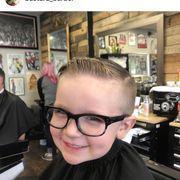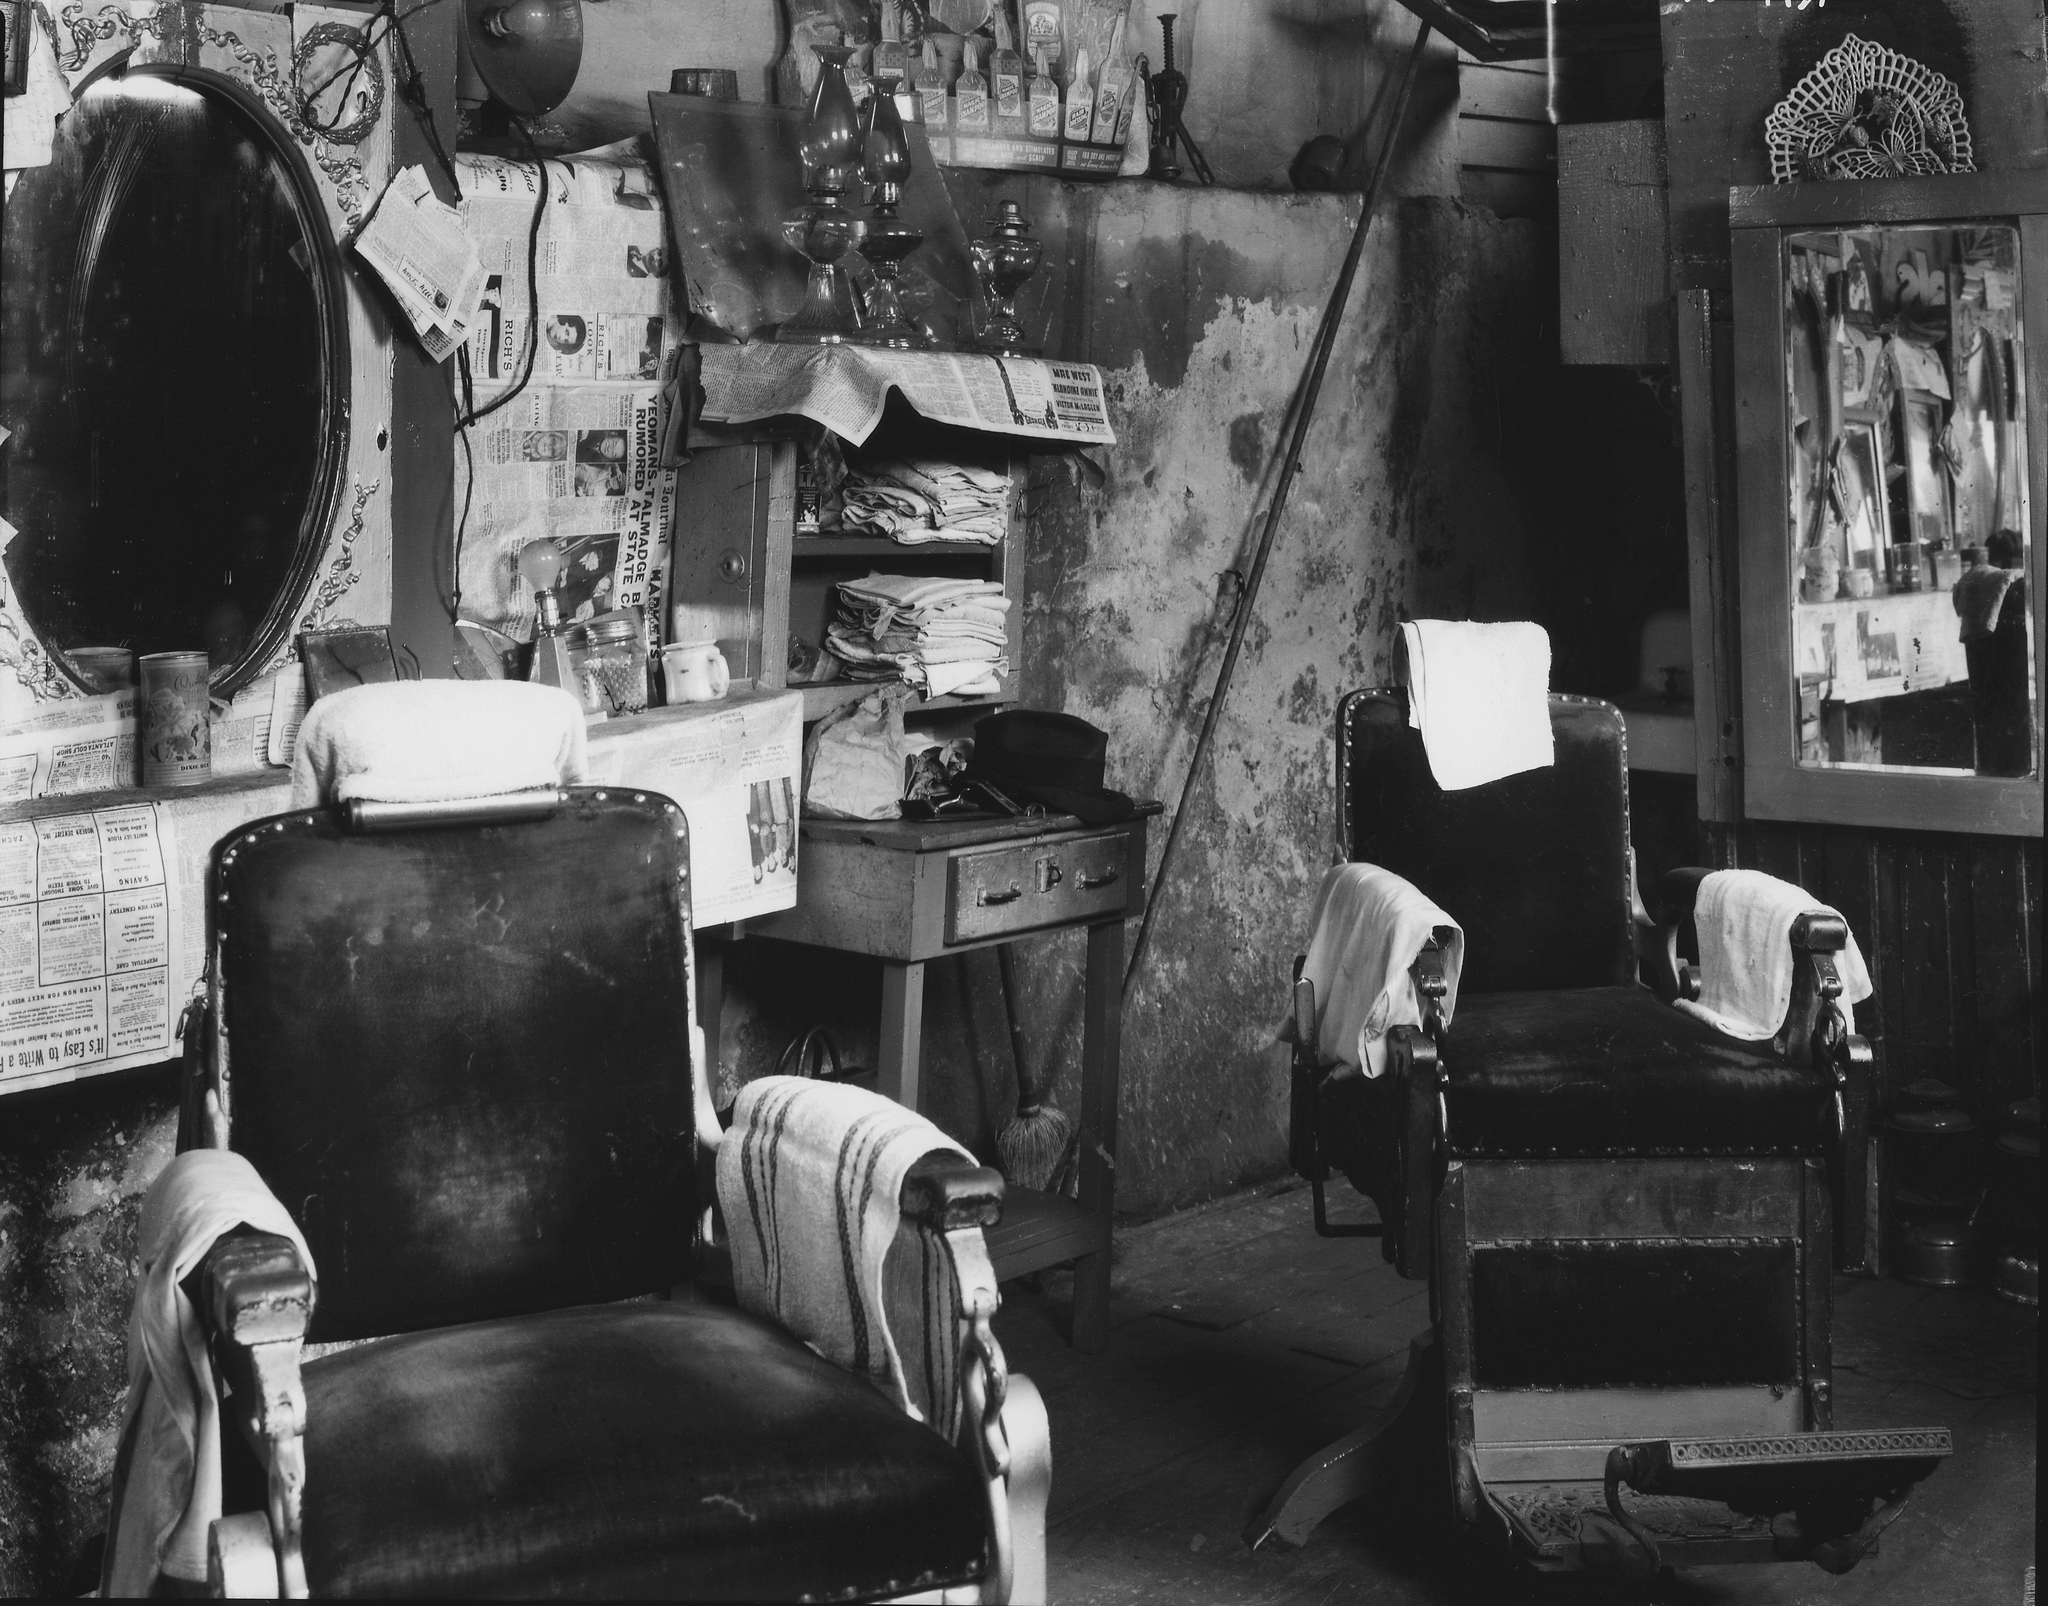The first image is the image on the left, the second image is the image on the right. Given the left and right images, does the statement "The left image includes a man in a hat, glasses and beard standing behind a forward-facing customer in a black smock." hold true? Answer yes or no. No. The first image is the image on the left, the second image is the image on the right. Examine the images to the left and right. Is the description "All of these images are in black and white." accurate? Answer yes or no. No. 